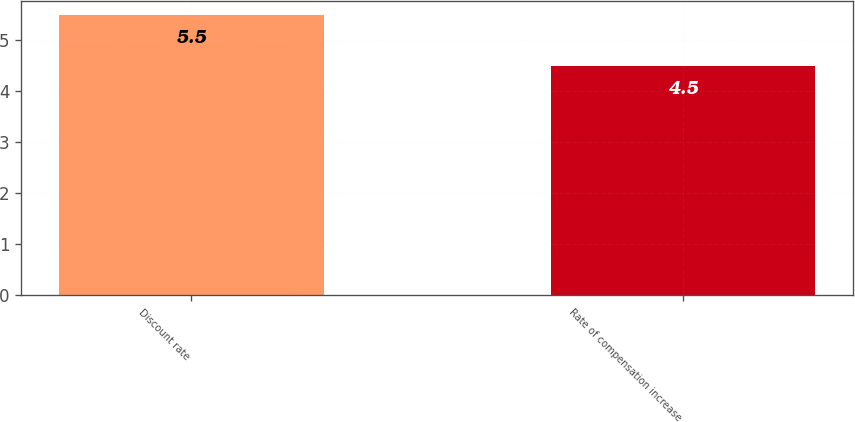Convert chart to OTSL. <chart><loc_0><loc_0><loc_500><loc_500><bar_chart><fcel>Discount rate<fcel>Rate of compensation increase<nl><fcel>5.5<fcel>4.5<nl></chart> 